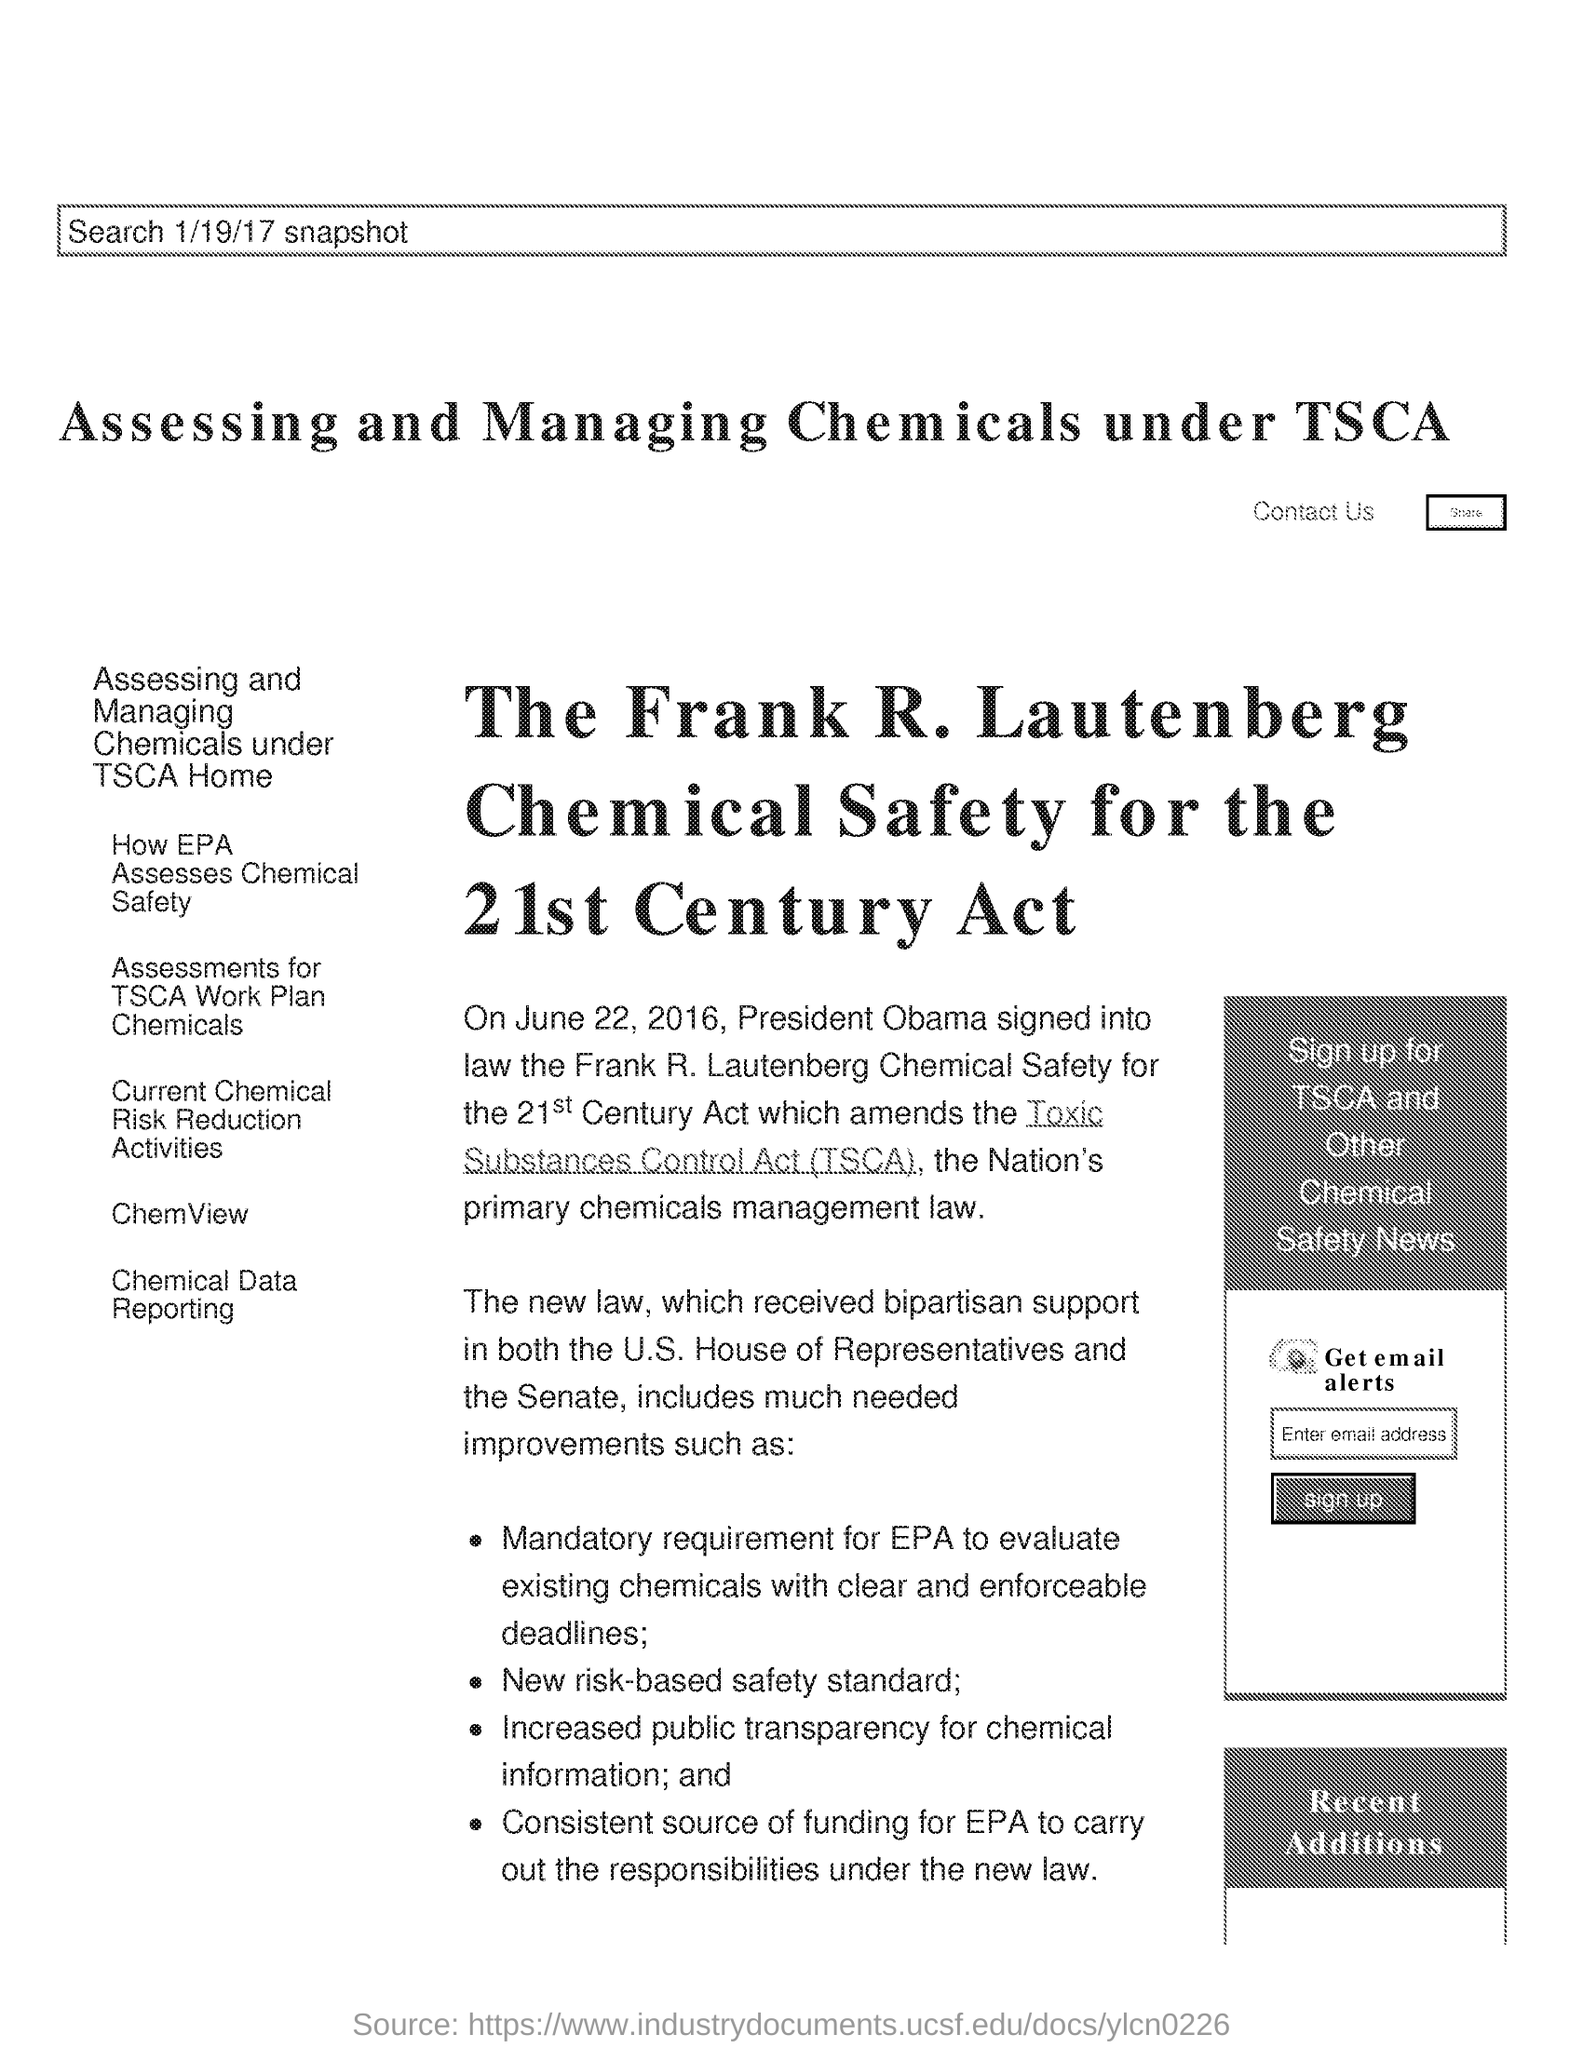Which law is signed by President Obama?
Offer a very short reply. The frank r. launtenberg chemical safety for 21st century act. What is the fullform of TSCA?
Offer a terse response. Toxic Substances Control Act. When did president Obama amends the TSCA?
Offer a terse response. On June 22, 2016. What was the Mandatory requirement for EPA?
Give a very brief answer. To evaluate existing chemicals with clear and enforceable deadlines. 